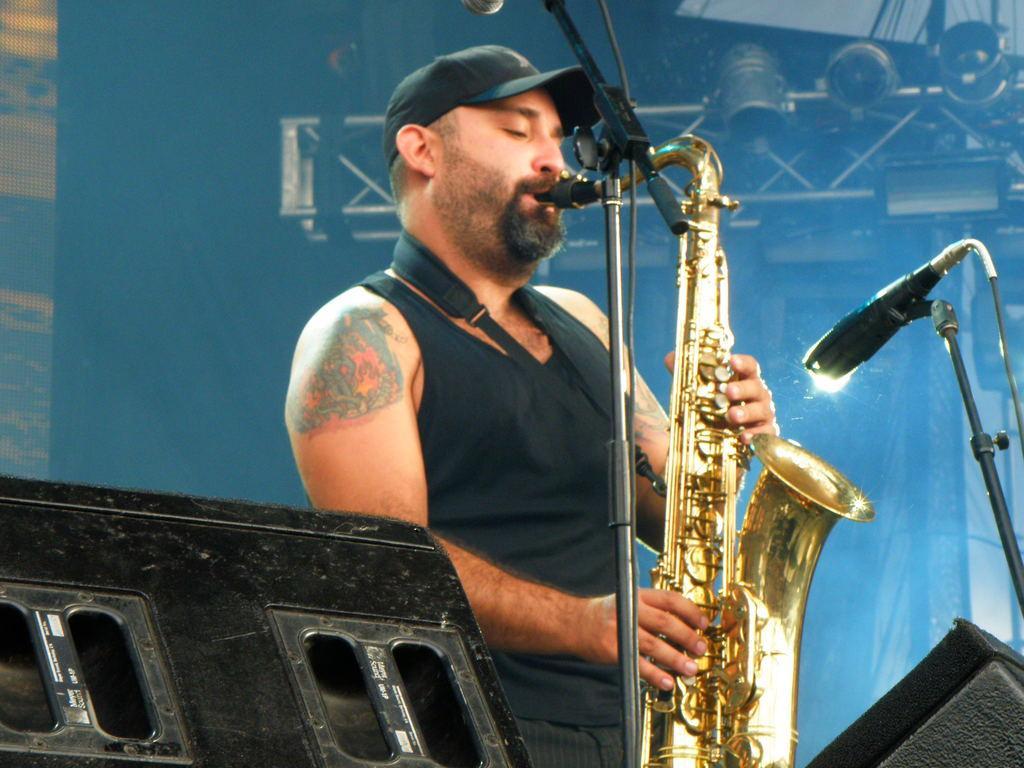In one or two sentences, can you explain what this image depicts? In this image there is a person holding a musical instrument, standing in front of mike's , at the bottom there are some objects, behind the person there may be a wall, iron stand. 